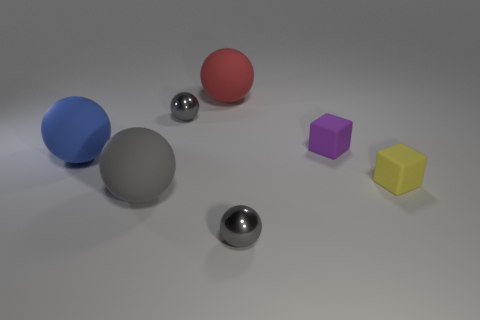Subtract all green cylinders. How many gray balls are left? 3 Subtract all red balls. How many balls are left? 4 Subtract all big gray rubber spheres. How many spheres are left? 4 Subtract all green spheres. Subtract all red cylinders. How many spheres are left? 5 Add 3 objects. How many objects exist? 10 Subtract all cubes. How many objects are left? 5 Subtract all spheres. Subtract all small metallic objects. How many objects are left? 0 Add 4 tiny yellow matte cubes. How many tiny yellow matte cubes are left? 5 Add 5 large blue objects. How many large blue objects exist? 6 Subtract 0 cyan cylinders. How many objects are left? 7 